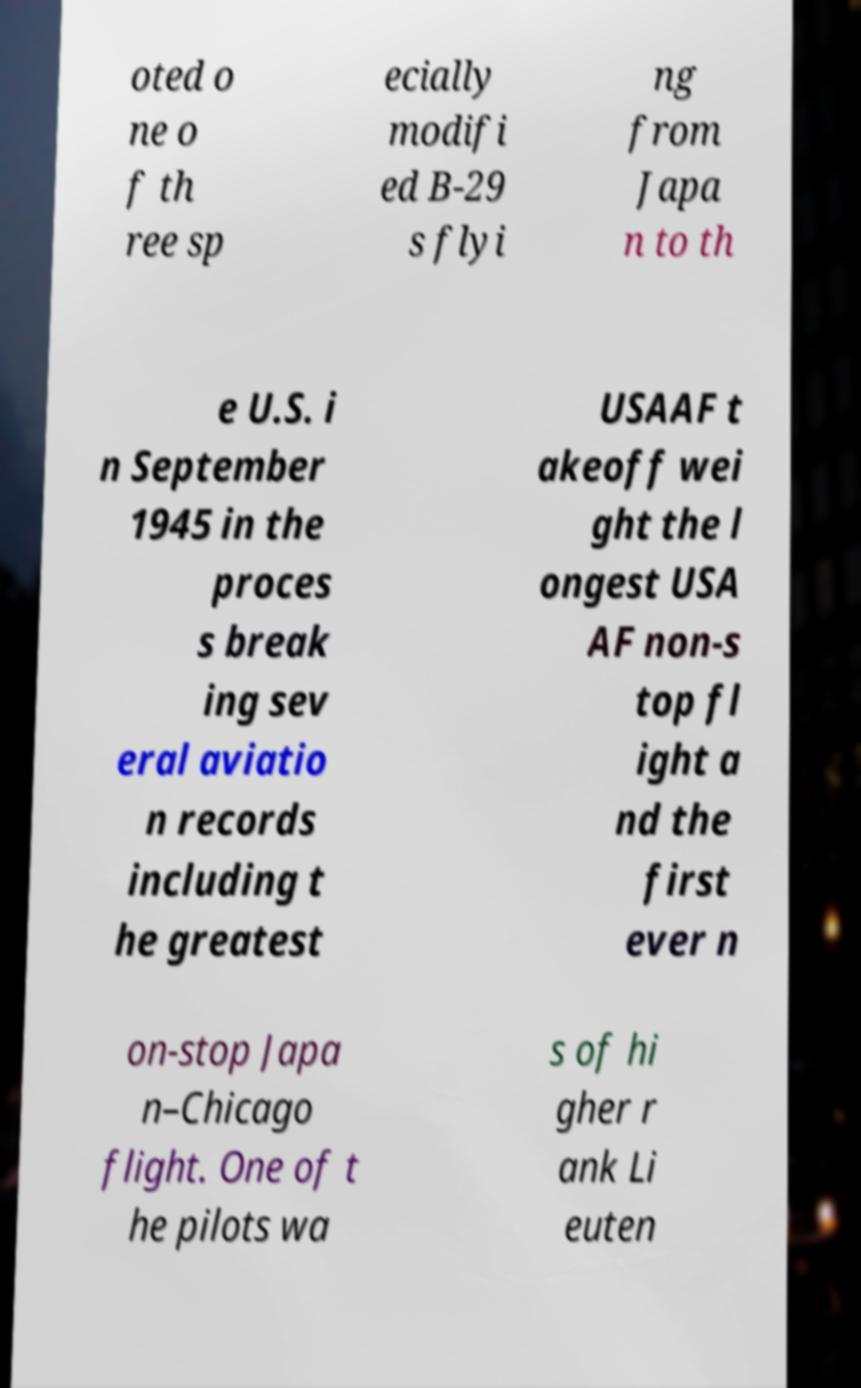Please identify and transcribe the text found in this image. oted o ne o f th ree sp ecially modifi ed B-29 s flyi ng from Japa n to th e U.S. i n September 1945 in the proces s break ing sev eral aviatio n records including t he greatest USAAF t akeoff wei ght the l ongest USA AF non-s top fl ight a nd the first ever n on-stop Japa n–Chicago flight. One of t he pilots wa s of hi gher r ank Li euten 